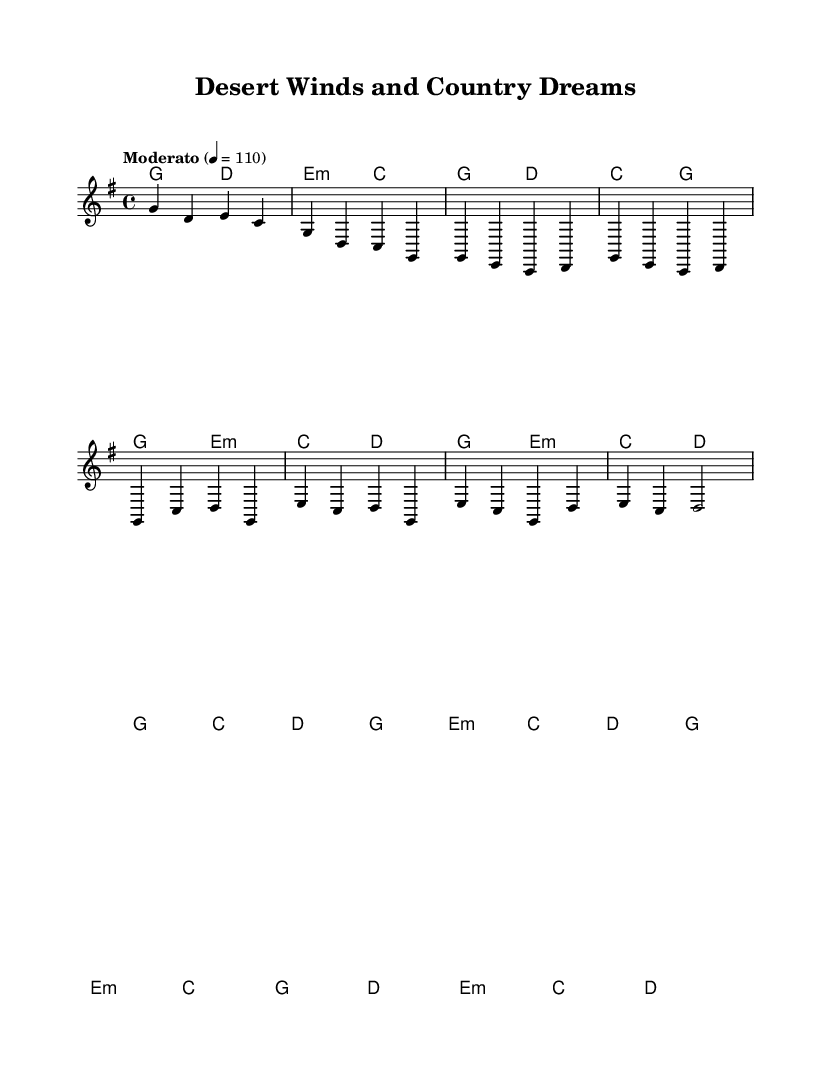What is the key signature of this music? The key signature is G major, which has one sharp (F#). This can be determined by looking at the key signature section of the music sheet, where G major is indicated.
Answer: G major What is the time signature of this piece? The time signature is 4/4, which means there are four beats in each measure and the quarter note gets one beat. This can be found at the beginning of the music sheet where the time signature is displayed.
Answer: 4/4 What is the tempo marking for the piece? The tempo marking is Moderato at 4 = 110, indicating a moderate speed of 110 beats per minute. This is stated at the beginning of the music, right underneath the time signature.
Answer: Moderato, 110 How many measures are in the intro section of the music? The intro consists of 4 measures, which can be counted by observing the bar lines that separate each measure within the intro section. Counting those gives a total of four.
Answer: 4 What chords are used in the chorus section? The chorus section uses the chords G, C, D, and E minor, which are indicated in the harmonies part for the measures corresponding to the chorus. These chords create the harmonic foundation of that section.
Answer: G, C, D, E minor How many sections does the piece consist of? The piece consists of four sections named Intro, Verse, Chorus, and Bridge. This can be identified by the structure of the music as noted in the melody and harmonies, which are laid out in distinct sections.
Answer: 4 What genre does this music primarily represent? The music primarily represents a fusion of Country Rock with elements of Rajasthani folk music, which is indicated by the combined stylistic traits in the melody and harmonies. The title "Desert Winds and Country Dreams" also reflects this fusion.
Answer: Country Rock 